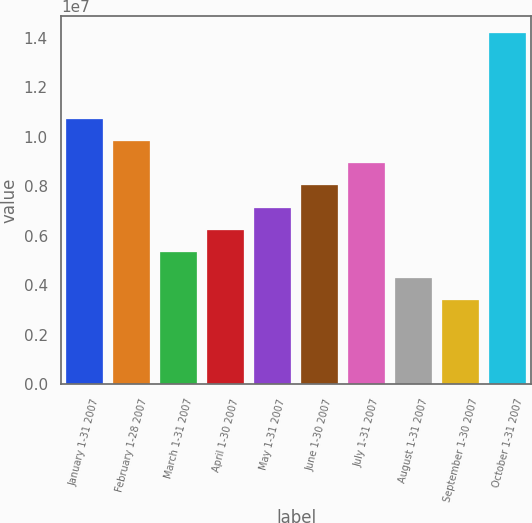Convert chart. <chart><loc_0><loc_0><loc_500><loc_500><bar_chart><fcel>January 1-31 2007<fcel>February 1-28 2007<fcel>March 1-31 2007<fcel>April 1-30 2007<fcel>May 1-31 2007<fcel>June 1-30 2007<fcel>July 1-31 2007<fcel>August 1-31 2007<fcel>September 1-30 2007<fcel>October 1-31 2007<nl><fcel>1.07287e+07<fcel>9.82866e+06<fcel>5.32866e+06<fcel>6.22866e+06<fcel>7.12866e+06<fcel>8.02866e+06<fcel>8.92866e+06<fcel>4.30152e+06<fcel>3.40152e+06<fcel>1.41646e+07<nl></chart> 